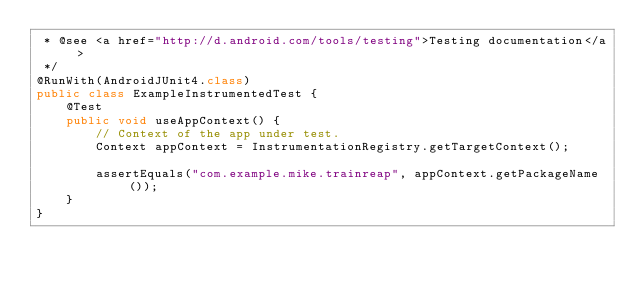Convert code to text. <code><loc_0><loc_0><loc_500><loc_500><_Java_> * @see <a href="http://d.android.com/tools/testing">Testing documentation</a>
 */
@RunWith(AndroidJUnit4.class)
public class ExampleInstrumentedTest {
    @Test
    public void useAppContext() {
        // Context of the app under test.
        Context appContext = InstrumentationRegistry.getTargetContext();

        assertEquals("com.example.mike.trainreap", appContext.getPackageName());
    }
}
</code> 